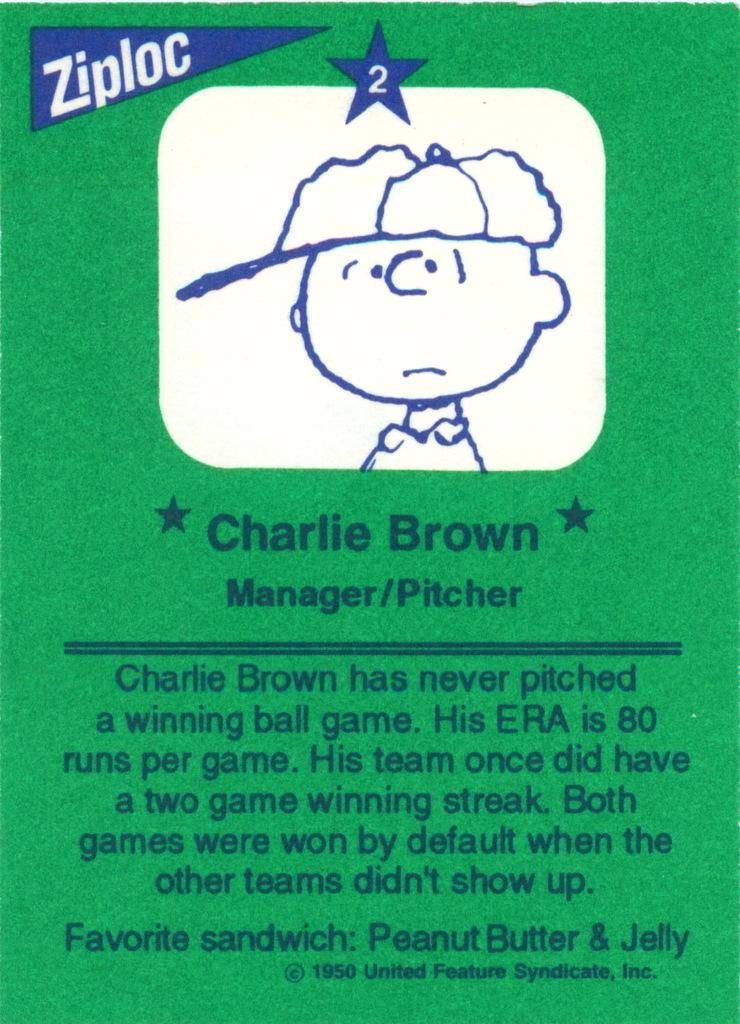What color is the object that can be seen in the image? The object in the image is green. What is featured on the green object? There is writing on the green object. Can you describe the sketch that is visible in the image? There is a sketch on the top side of the image. How many giraffes can be seen interacting with the sketch in the image? There are no giraffes present in the image; it features a green object with writing and a sketch. What type of friction is created by the interaction between the green object and the sketch? There is no information about friction in the image, as it only shows a green object with writing and a sketch. 